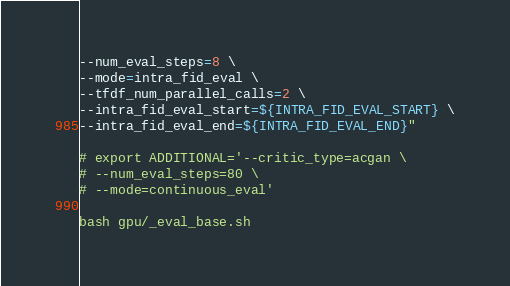Convert code to text. <code><loc_0><loc_0><loc_500><loc_500><_Bash_>--num_eval_steps=8 \
--mode=intra_fid_eval \
--tfdf_num_parallel_calls=2 \
--intra_fid_eval_start=${INTRA_FID_EVAL_START} \
--intra_fid_eval_end=${INTRA_FID_EVAL_END}"

# export ADDITIONAL='--critic_type=acgan \
# --num_eval_steps=80 \
# --mode=continuous_eval'

bash gpu/_eval_base.sh</code> 